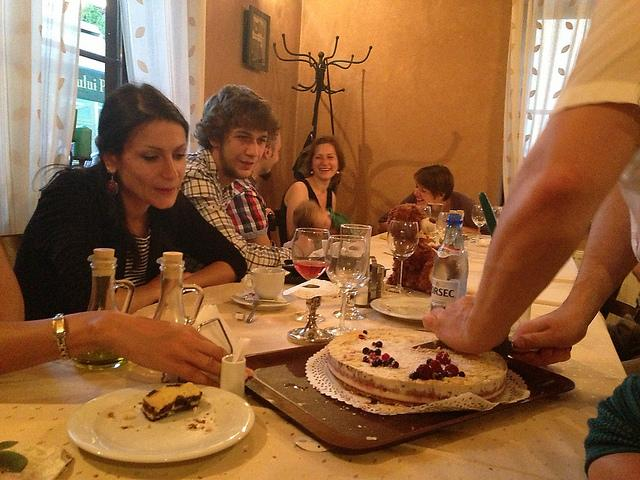What will the people shown here have for dessert?

Choices:
A) waffles
B) ice cream
C) pie
D) cheesecake cheesecake 